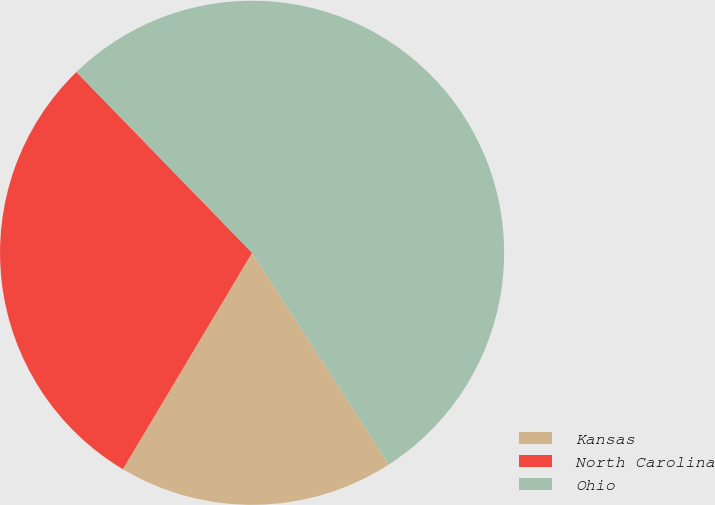Convert chart to OTSL. <chart><loc_0><loc_0><loc_500><loc_500><pie_chart><fcel>Kansas<fcel>North Carolina<fcel>Ohio<nl><fcel>17.7%<fcel>29.16%<fcel>53.13%<nl></chart> 